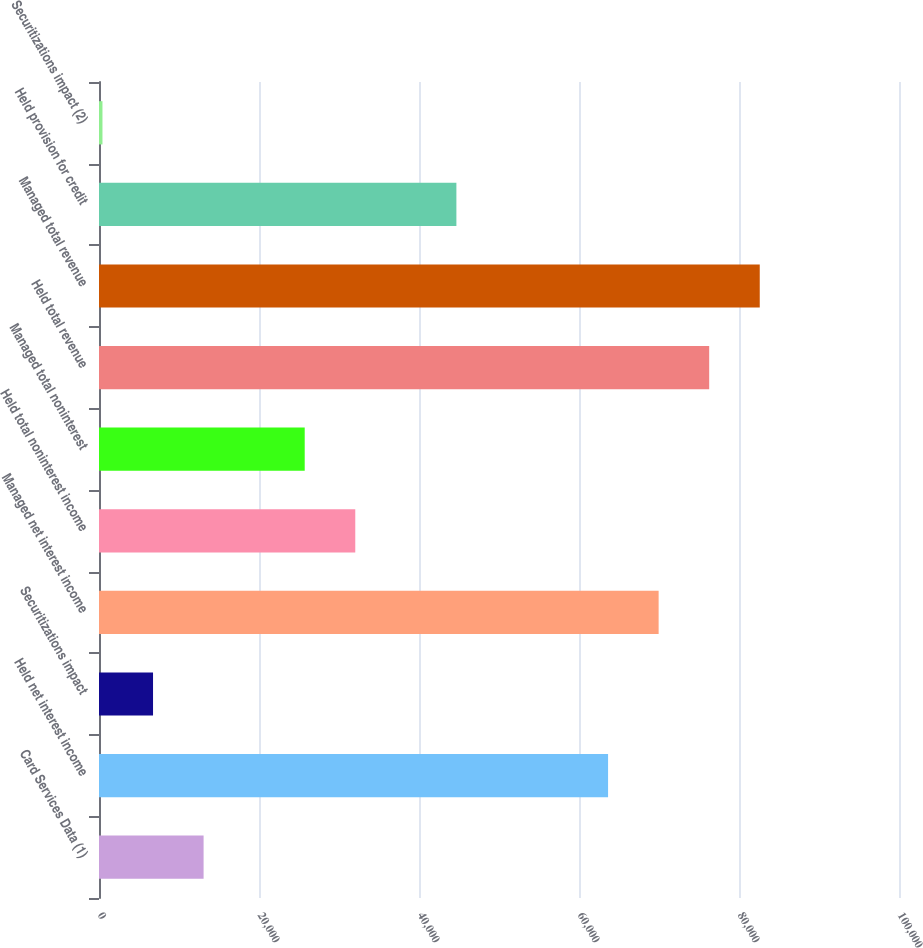<chart> <loc_0><loc_0><loc_500><loc_500><bar_chart><fcel>Card Services Data (1)<fcel>Held net interest income<fcel>Securitizations impact<fcel>Managed net interest income<fcel>Held total noninterest income<fcel>Managed total noninterest<fcel>Held total revenue<fcel>Managed total revenue<fcel>Held provision for credit<fcel>Securitizations impact (2)<nl><fcel>13074<fcel>63634<fcel>6754<fcel>69954<fcel>32034<fcel>25714<fcel>76274<fcel>82594<fcel>44674<fcel>434<nl></chart> 